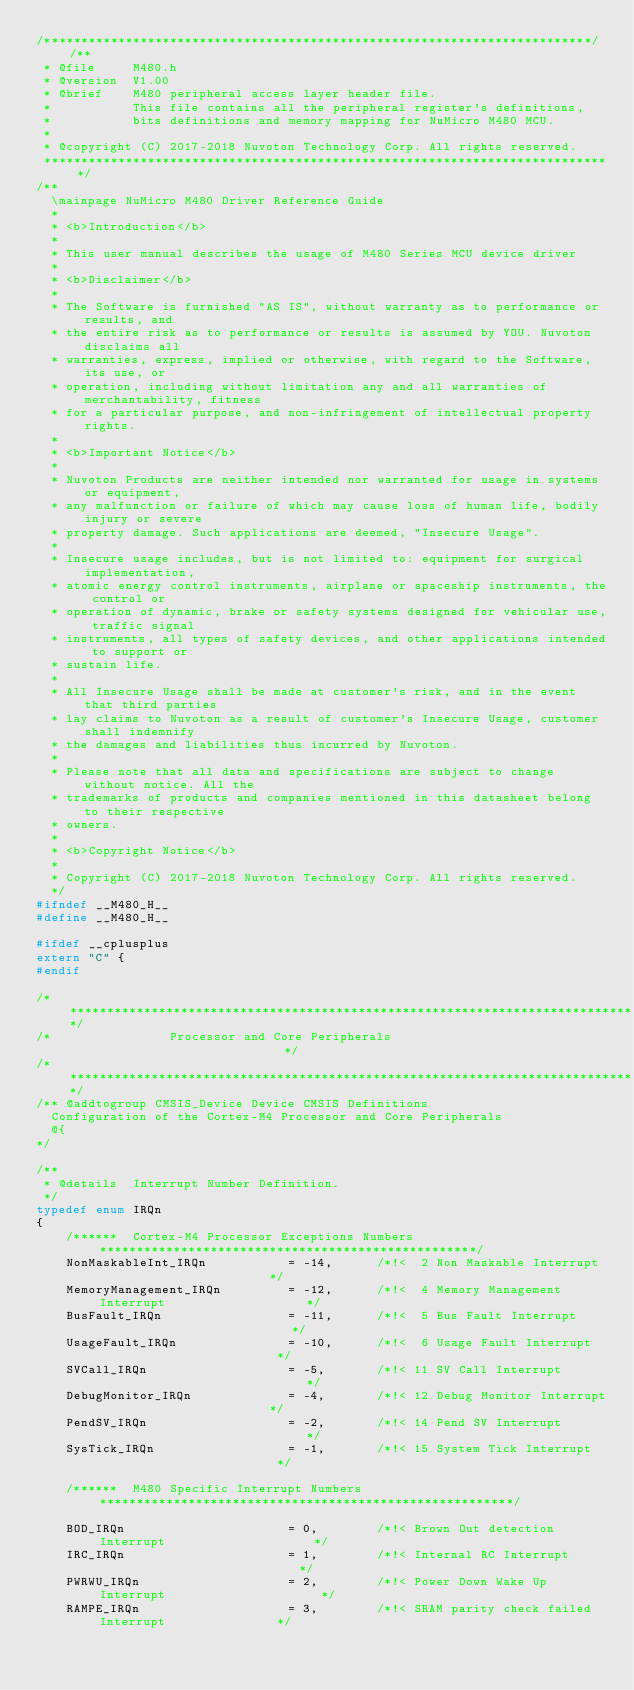Convert code to text. <code><loc_0><loc_0><loc_500><loc_500><_C_>/**************************************************************************//**
 * @file     M480.h
 * @version  V1.00
 * @brief    M480 peripheral access layer header file.
 *           This file contains all the peripheral register's definitions,
 *           bits definitions and memory mapping for NuMicro M480 MCU.
 *
 * @copyright (C) 2017-2018 Nuvoton Technology Corp. All rights reserved.
 *****************************************************************************/
/**
  \mainpage NuMicro M480 Driver Reference Guide
  *
  * <b>Introduction</b>
  *
  * This user manual describes the usage of M480 Series MCU device driver
  *
  * <b>Disclaimer</b>
  *
  * The Software is furnished "AS IS", without warranty as to performance or results, and
  * the entire risk as to performance or results is assumed by YOU. Nuvoton disclaims all
  * warranties, express, implied or otherwise, with regard to the Software, its use, or
  * operation, including without limitation any and all warranties of merchantability, fitness
  * for a particular purpose, and non-infringement of intellectual property rights.
  *
  * <b>Important Notice</b>
  *
  * Nuvoton Products are neither intended nor warranted for usage in systems or equipment,
  * any malfunction or failure of which may cause loss of human life, bodily injury or severe
  * property damage. Such applications are deemed, "Insecure Usage".
  *
  * Insecure usage includes, but is not limited to: equipment for surgical implementation,
  * atomic energy control instruments, airplane or spaceship instruments, the control or
  * operation of dynamic, brake or safety systems designed for vehicular use, traffic signal
  * instruments, all types of safety devices, and other applications intended to support or
  * sustain life.
  *
  * All Insecure Usage shall be made at customer's risk, and in the event that third parties
  * lay claims to Nuvoton as a result of customer's Insecure Usage, customer shall indemnify
  * the damages and liabilities thus incurred by Nuvoton.
  *
  * Please note that all data and specifications are subject to change without notice. All the
  * trademarks of products and companies mentioned in this datasheet belong to their respective
  * owners.
  *
  * <b>Copyright Notice</b>
  *
  * Copyright (C) 2017-2018 Nuvoton Technology Corp. All rights reserved.
  */
#ifndef __M480_H__
#define __M480_H__

#ifdef __cplusplus
extern "C" {
#endif

/******************************************************************************/
/*                Processor and Core Peripherals                              */
/******************************************************************************/
/** @addtogroup CMSIS_Device Device CMSIS Definitions
  Configuration of the Cortex-M4 Processor and Core Peripherals
  @{
*/

/**
 * @details  Interrupt Number Definition.
 */
typedef enum IRQn
{
    /******  Cortex-M4 Processor Exceptions Numbers ***************************************************/
    NonMaskableInt_IRQn           = -14,      /*!<  2 Non Maskable Interrupt                        */
    MemoryManagement_IRQn         = -12,      /*!<  4 Memory Management Interrupt                   */
    BusFault_IRQn                 = -11,      /*!<  5 Bus Fault Interrupt                           */
    UsageFault_IRQn               = -10,      /*!<  6 Usage Fault Interrupt                         */
    SVCall_IRQn                   = -5,       /*!< 11 SV Call Interrupt                             */
    DebugMonitor_IRQn             = -4,       /*!< 12 Debug Monitor Interrupt                       */
    PendSV_IRQn                   = -2,       /*!< 14 Pend SV Interrupt                             */
    SysTick_IRQn                  = -1,       /*!< 15 System Tick Interrupt                         */

    /******  M480 Specific Interrupt Numbers ********************************************************/

    BOD_IRQn                      = 0,        /*!< Brown Out detection Interrupt                    */
    IRC_IRQn                      = 1,        /*!< Internal RC Interrupt                            */
    PWRWU_IRQn                    = 2,        /*!< Power Down Wake Up Interrupt                     */
    RAMPE_IRQn                    = 3,        /*!< SRAM parity check failed Interrupt               */</code> 